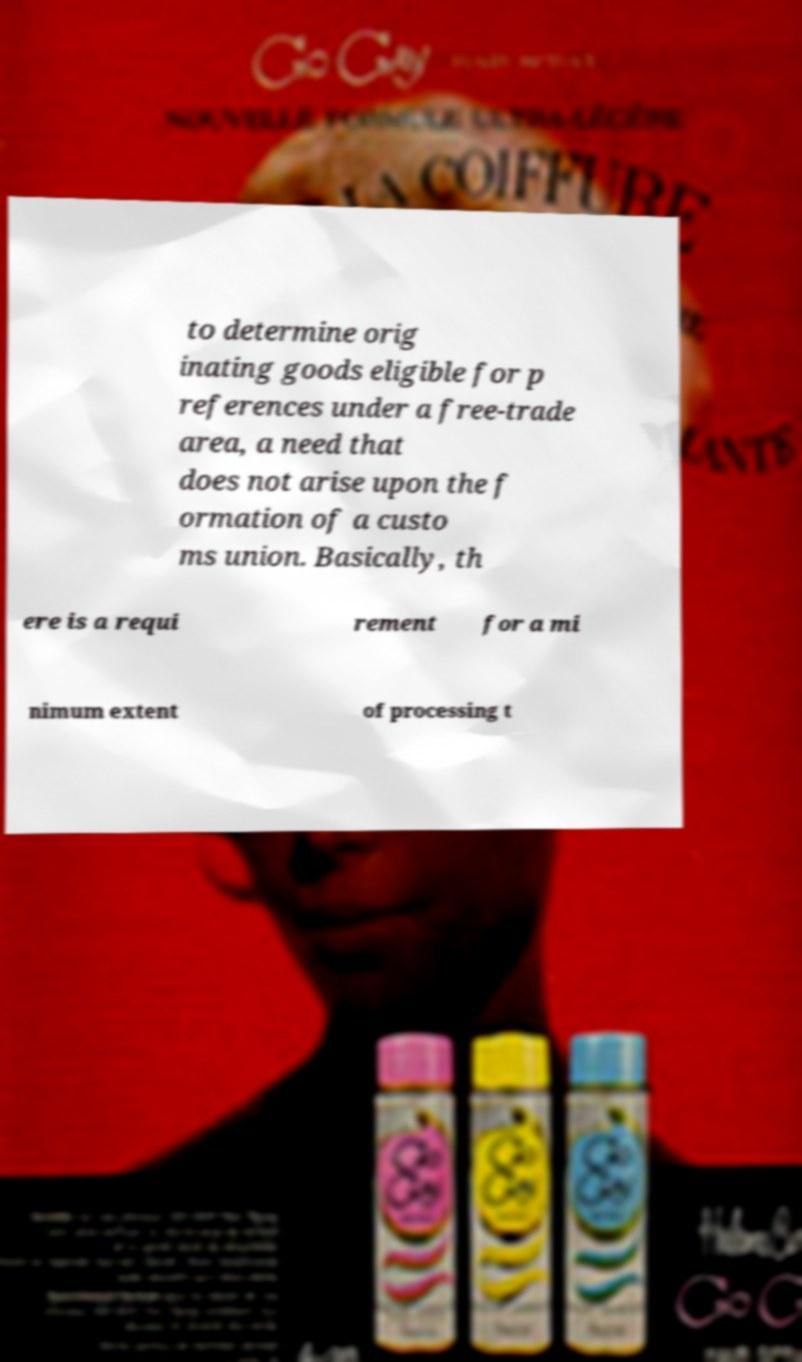Please identify and transcribe the text found in this image. to determine orig inating goods eligible for p references under a free-trade area, a need that does not arise upon the f ormation of a custo ms union. Basically, th ere is a requi rement for a mi nimum extent of processing t 